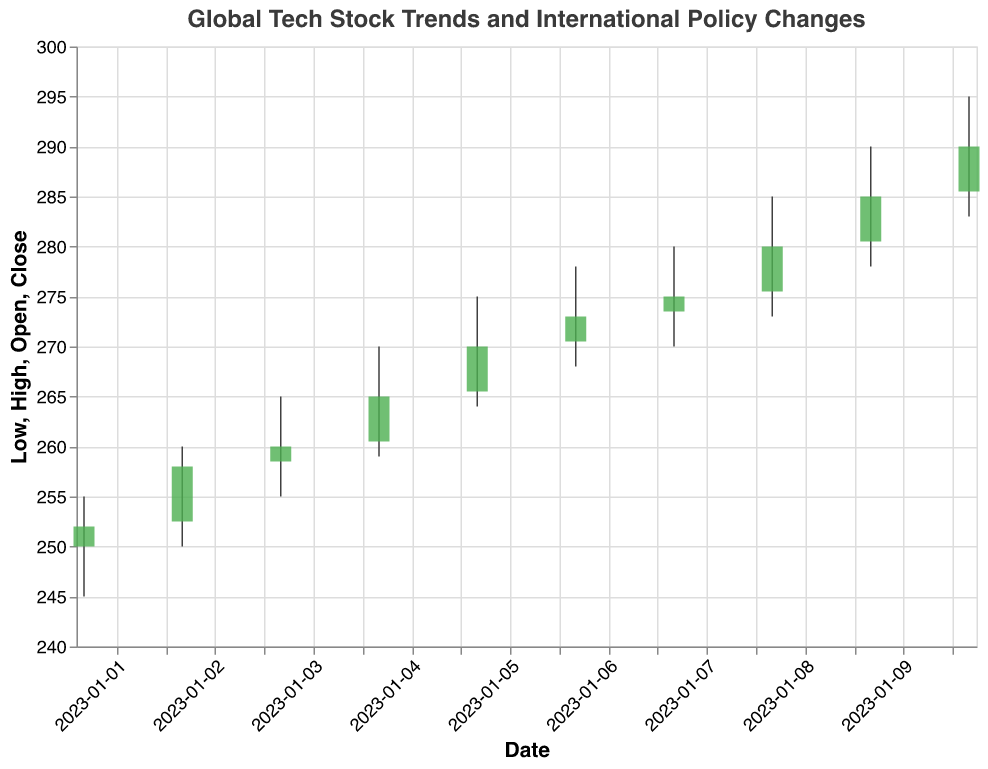What is the overall trend in the stock prices from January 1 to January 10? The overall trend in stock prices is observed by looking at the closing prices each day. Starting from January 1 with a closing price of 252.00 and ending on January 10 with a closing price of 290.00, the stock prices are generally increasing.
Answer: Increasing Which date had the highest trading volume? Look at the volume values for each date. The highest volume is 1,420,000 on January 10.
Answer: January 10 How did the stock price react to the announcement of the European data protection law on January 5? The closing price on January 4 was 265.00. After the announcement, on January 5, the closing price increased to 270.00.
Answer: Increased What was the lowest stock price recorded between January 1 and January 10? Examine the "Low" column; the lowest price recorded is 245.00 on January 1.
Answer: 245.00 On which date did the stock price have the greatest single-day increase in closing price? Compare the daily changes in closing prices. The largest increase is 5.00, from 275.00 on January 8 to 280.00 on January 9.
Answer: January 9 Compare the closing prices on January 1 and January 3. Which date had a higher closing price? The closing price on January 1 was 252.00, and on January 3, it was 260.00, so January 3 had a higher closing price.
Answer: January 3 How did the announcement of new tech investments in emerging markets on January 10 impact the stock price? The closing price increased from 285.00 on January 9 to 290.00 on January 10.
Answer: Increased What was the total volume traded over the entire period? Sum the volumes from each day: 1,200,000 + 1,120,000 + 1,150,000 + 1,180,000 + 1,300,000 + 1,250,000 + 1,220,000 + 1,350,000 + 1,400,000 + 1,420,000 = 12,590,000.
Answer: 12,590,000 Which event corresponded to the highest closing price in the dataset? The highest closing price is 290.00 on January 10, which is associated with "New tech investments in emerging markets."
Answer: New tech investments in emerging markets 